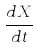Convert formula to latex. <formula><loc_0><loc_0><loc_500><loc_500>\frac { d X } { d t }</formula> 